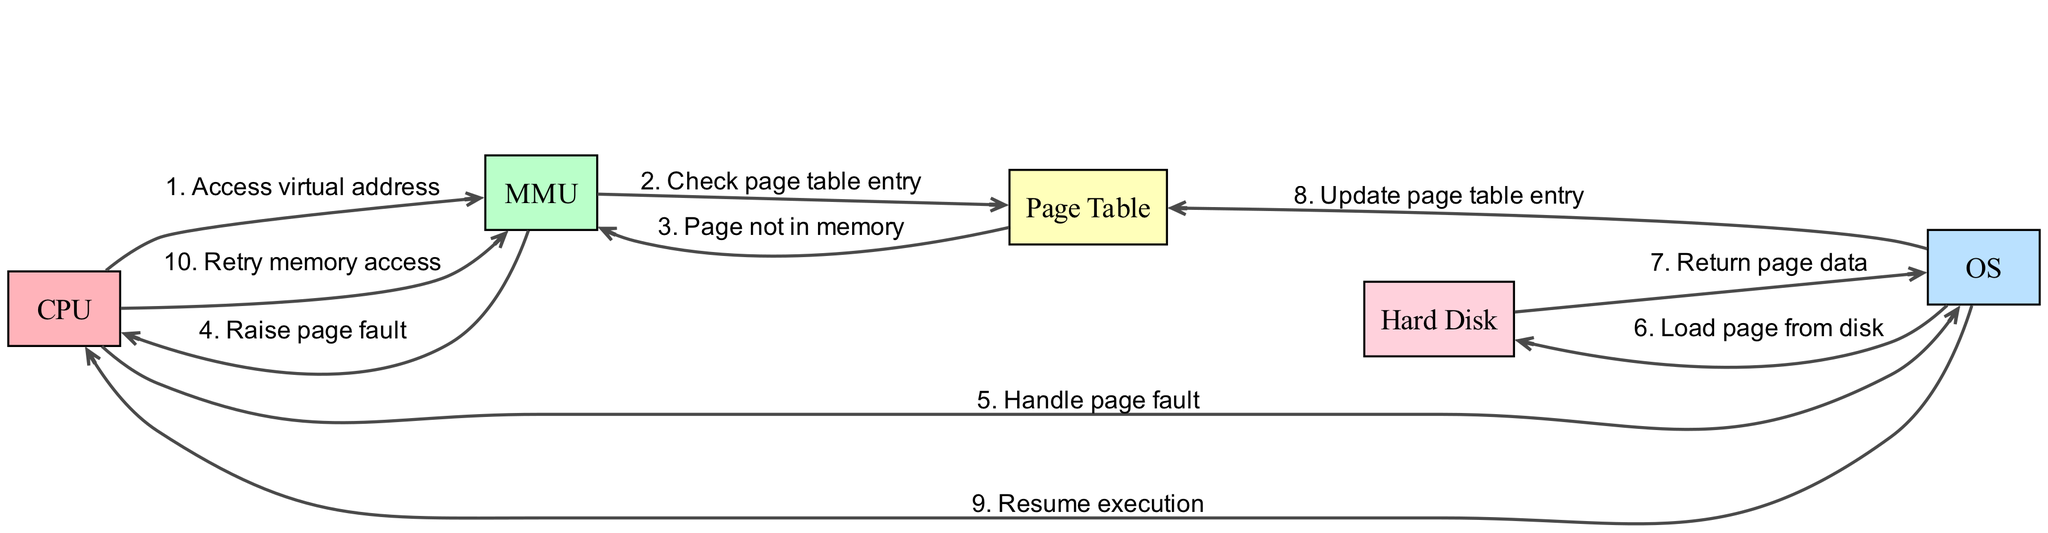What is the first action taken in this sequence? The first action in the sequence is initiated by the CPU when it accesses a virtual address. This is the starting point of the diagram and establishes the context for subsequent actions.
Answer: Access virtual address Which actor raises the page fault? The MMU checks the page table entry and if it finds that the page is not in memory, it raises a page fault. This is the specific action that indicates an error state in memory management.
Answer: Raise page fault How many actors are involved in the diagram? The diagram features five distinct actors: CPU, MMU, OS, Page Table, and Hard Disk. Each of these actors plays a role in the page fault handling process.
Answer: 5 What does the OS do after receiving the page fault request from the CPU? Upon receiving the page fault request, the OS proceeds to handle it by loading the required page from the hard disk. This is a critical step in ensuring that the memory access can continue successfully.
Answer: Load page from disk What is the final action taken in this sequence before the CPU retries memory access? The final action before the CPU retries memory access is the OS resuming execution. This is essential as it allows the CPU to continue its operations after handling the page fault.
Answer: Resume execution What does the OS update after loading the page from the hard disk? The OS updates the page table entry to reflect that the page has been brought into memory. This ensures that future accesses to this page will succeed without additional faults.
Answer: Update page table entry What message does the Page Table send to the MMU after a check is performed? The Page Table sends a message indicating that the page is not in memory after the MMU checks the page table entry. This message triggers the fault-handling sequence.
Answer: Page not in memory What does the Hard Disk return to the OS? The Hard Disk returns the page data to the OS, which is necessary to complete the memory access that caused the page fault. This data transfer is crucial for resolving the page fault.
Answer: Return page data 